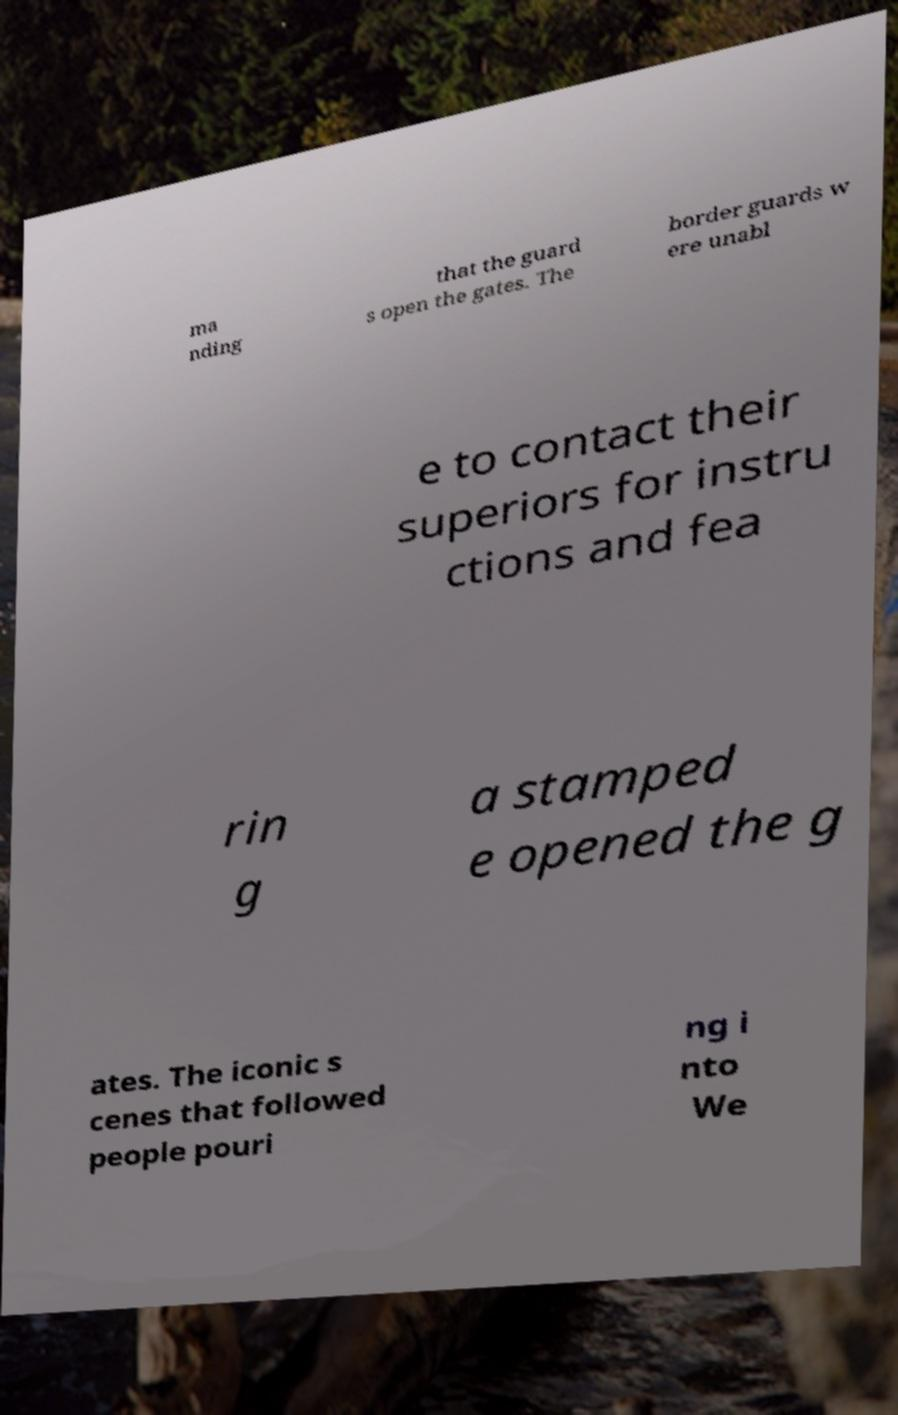Please read and relay the text visible in this image. What does it say? ma nding that the guard s open the gates. The border guards w ere unabl e to contact their superiors for instru ctions and fea rin g a stamped e opened the g ates. The iconic s cenes that followed people pouri ng i nto We 